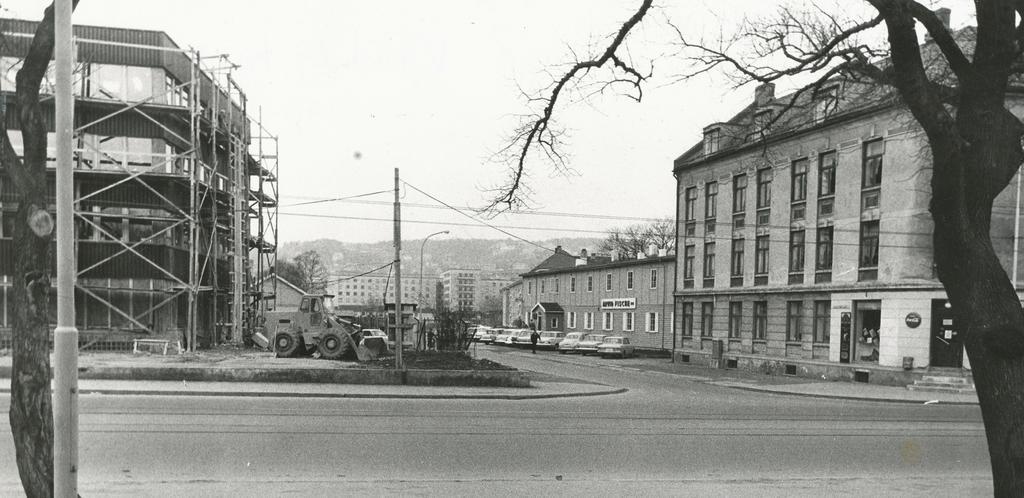Could you give a brief overview of what you see in this image? In this image I can see few roads, a pole and two trees in the front. In the background I can see number of buildings, number of vehicles, few more poles, a street light, wires and few trees. I can also see one person in the background and on the right side of the image I can see few boards on the buildings. I can also see something is written on these boards and I can see this image is black and white in colour. 